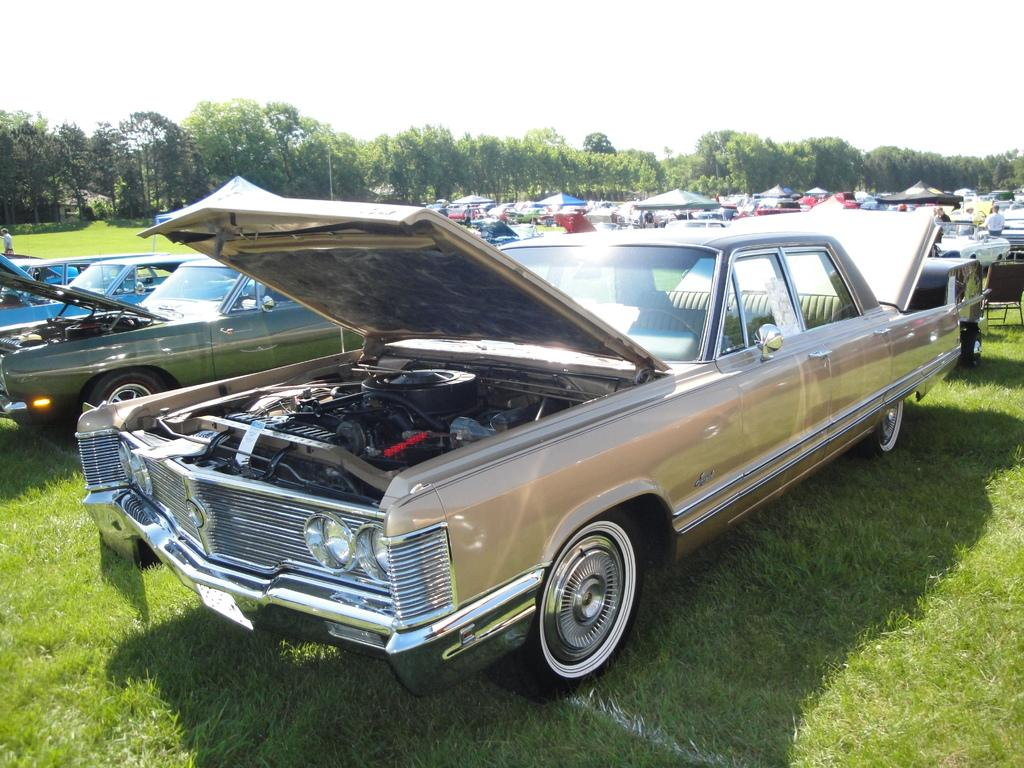What types of objects can be seen in the image? There are vehicles, a chair, umbrellas, and poles visible in the image. Are there any living beings in the image? Yes, there are people in the image. What is the ground like in the image? The ground with grass is visible in the image. What can be seen in the background of the image? Trees and the sky are visible in the background of the image. Can you tell me how many yaks are grazing on the grass in the image? There are no yaks present in the image; it features vehicles, a chair, umbrellas, poles, people, trees, and the sky. What type of quartz can be seen in the image? There is no quartz present in the image. 